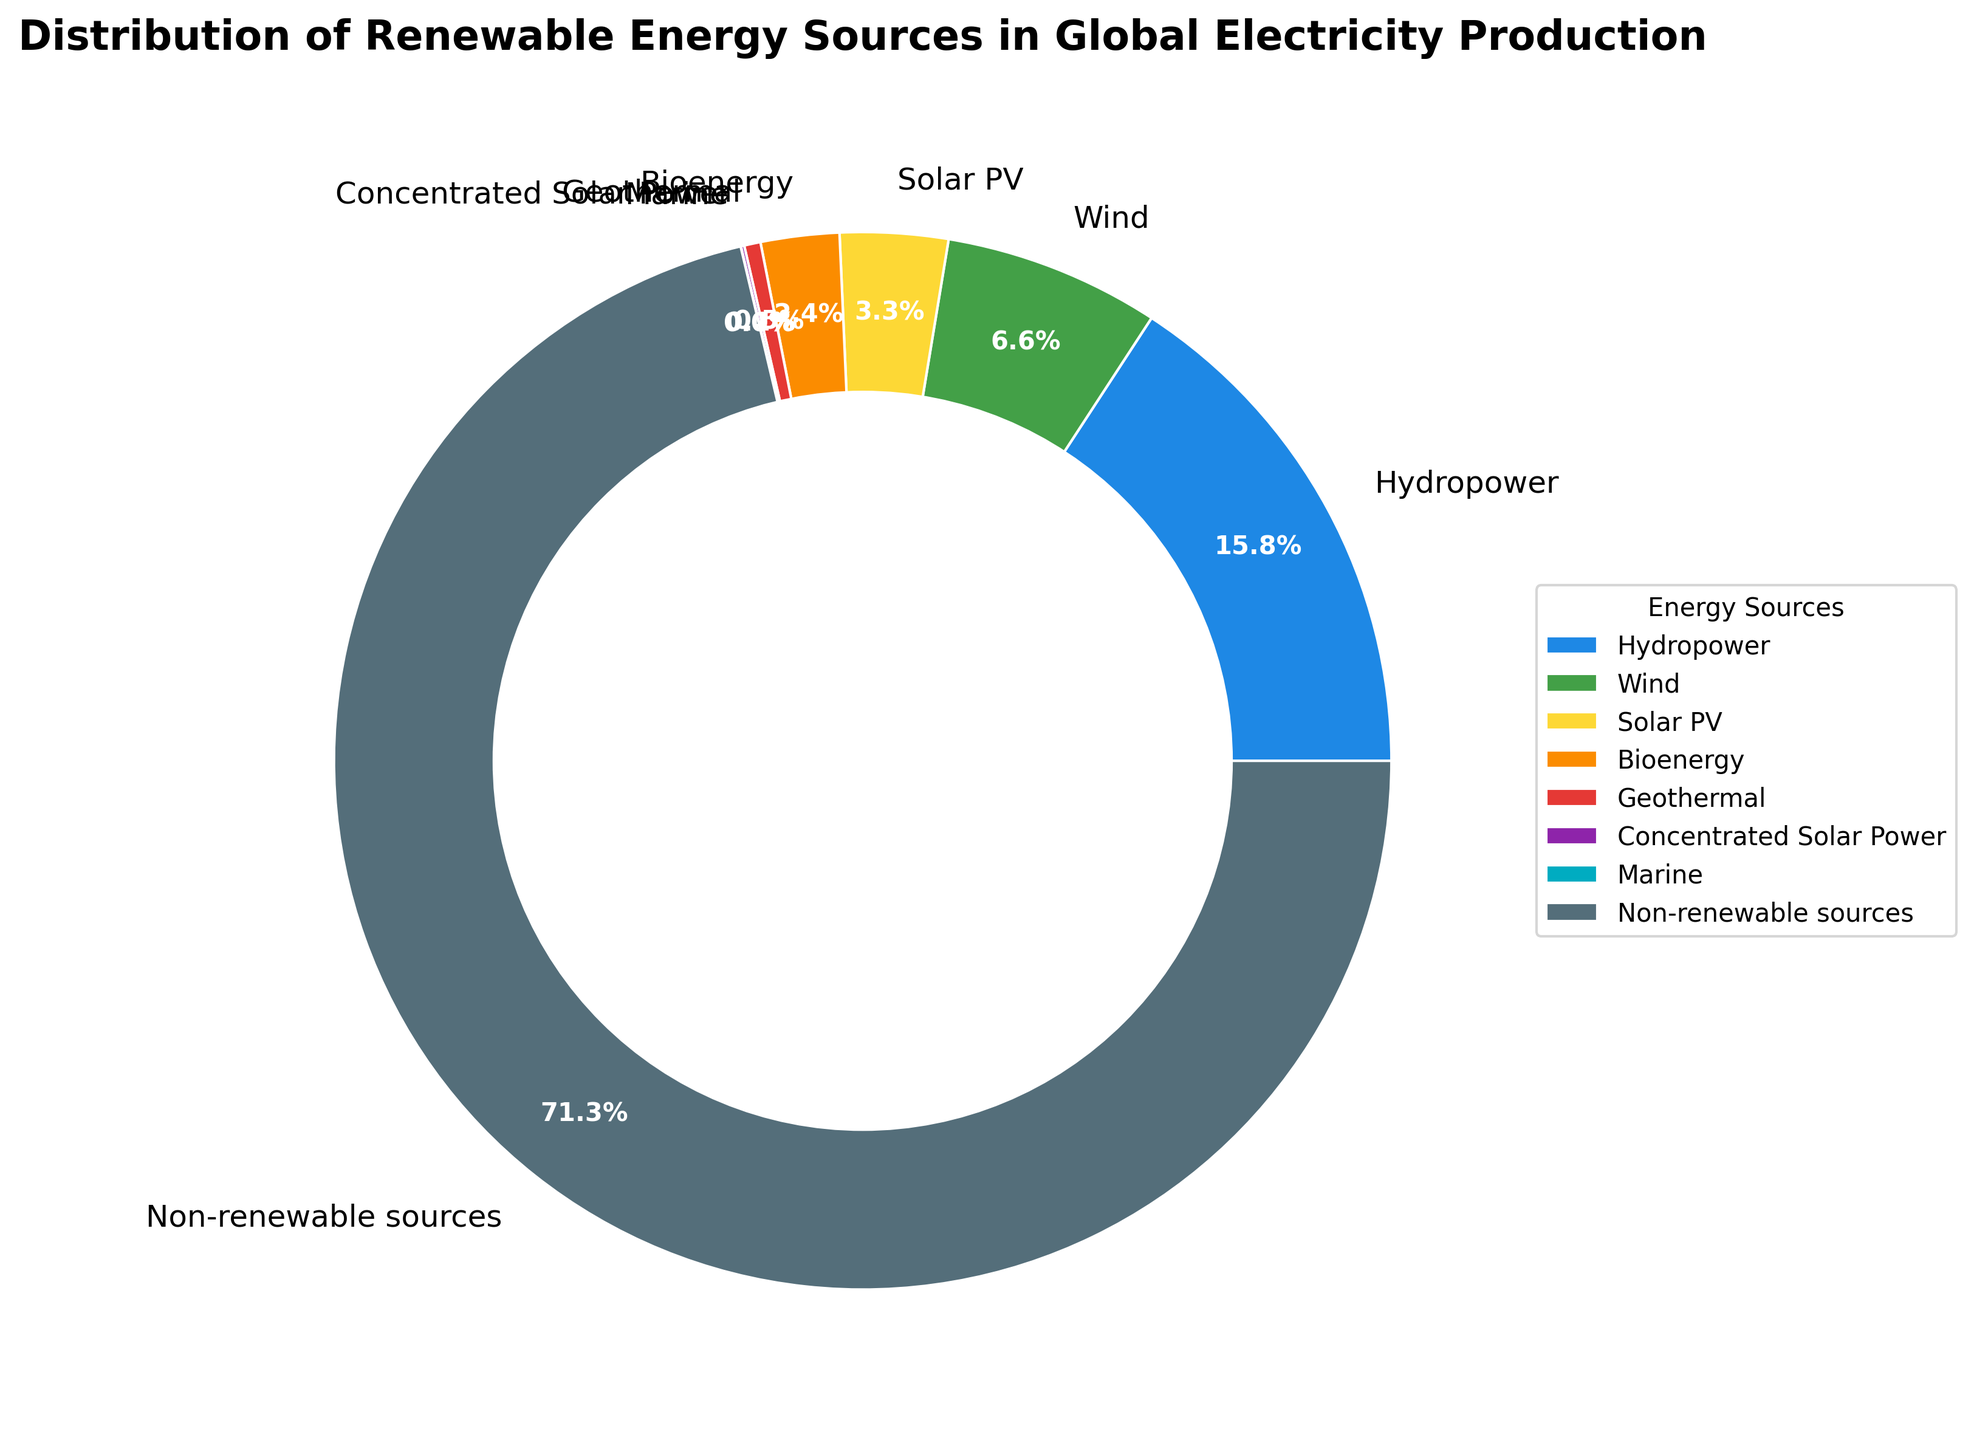Which renewable energy source contributes the most to global electricity production? The slice representing 'Hydropower' is the largest among renewable sources in the pie chart, indicating it has the highest contribution.
Answer: Hydropower Which two renewable sources combined account for more than 50% of renewable energy production but less than 50% of the total global electricity production? Adding percentages for 'Hydropower' (15.8%) and 'Wind' (6.6%) gives 22.4%. These two sources together account for 22.4%, which is more than half of the total renewable share without exceeding 50% of the global electricity production.
Answer: Hydropower and Wind How does the contribution of Solar PV compare to Bioenergy? 'Solar PV' has a slice labeled with 3.3%, while 'Bioenergy' has a slice labeled with 2.4%. Solar PV contributes a higher percentage than Bioenergy.
Answer: Solar PV is higher What is the approximate total percentage contribution of geothermal, marine, and concentrated solar power combined? Adding the percentages for 'Geothermal' (0.5%), 'Marine' (0.01%), and 'Concentrated Solar Power' (0.1%) yields 0.5 + 0.01 + 0.1 = 0.61%.
Answer: 0.61% Which non-renewable sources contribute the majority of the global electricity production? The slice labeled 'Non-renewable sources' is clearly the largest slice and is labeled 71.29%, indicating that non-renewable sources contribute the majority of the global electricity production.
Answer: Non-renewable sources What is the difference between the contributions of Wind and Geothermal to global electricity production? The pie chart shows Wind with 6.6% and Geothermal with 0.5%. Subtracting these gives 6.6% - 0.5% = 6.1%.
Answer: 6.1% What color represents the slice for Bioenergy? The slice labeled 'Bioenergy' is shown in orange in the pie chart.
Answer: Orange Which energy source has the least contribution to global electricity production? The slice labeled 'Marine' is the smallest and is labeled with 0.01%, making it the least contributor among the sources listed.
Answer: Marine 